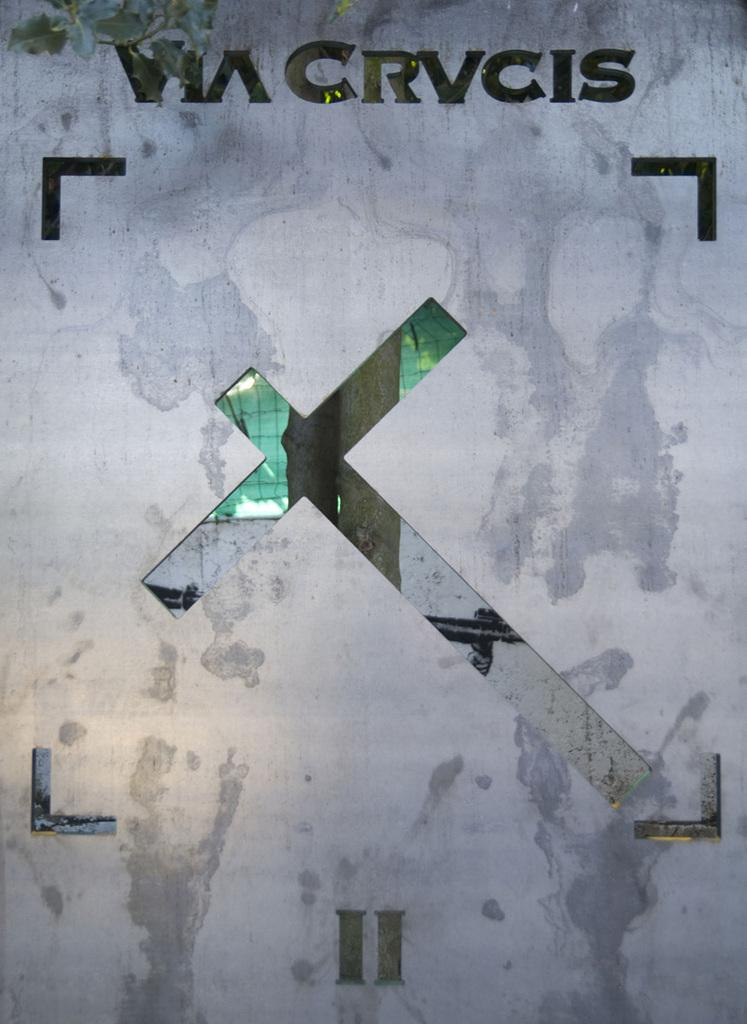Provide a one-sentence caption for the provided image. Via Crvcis wrote on a wallpaper with an x in the middle. 